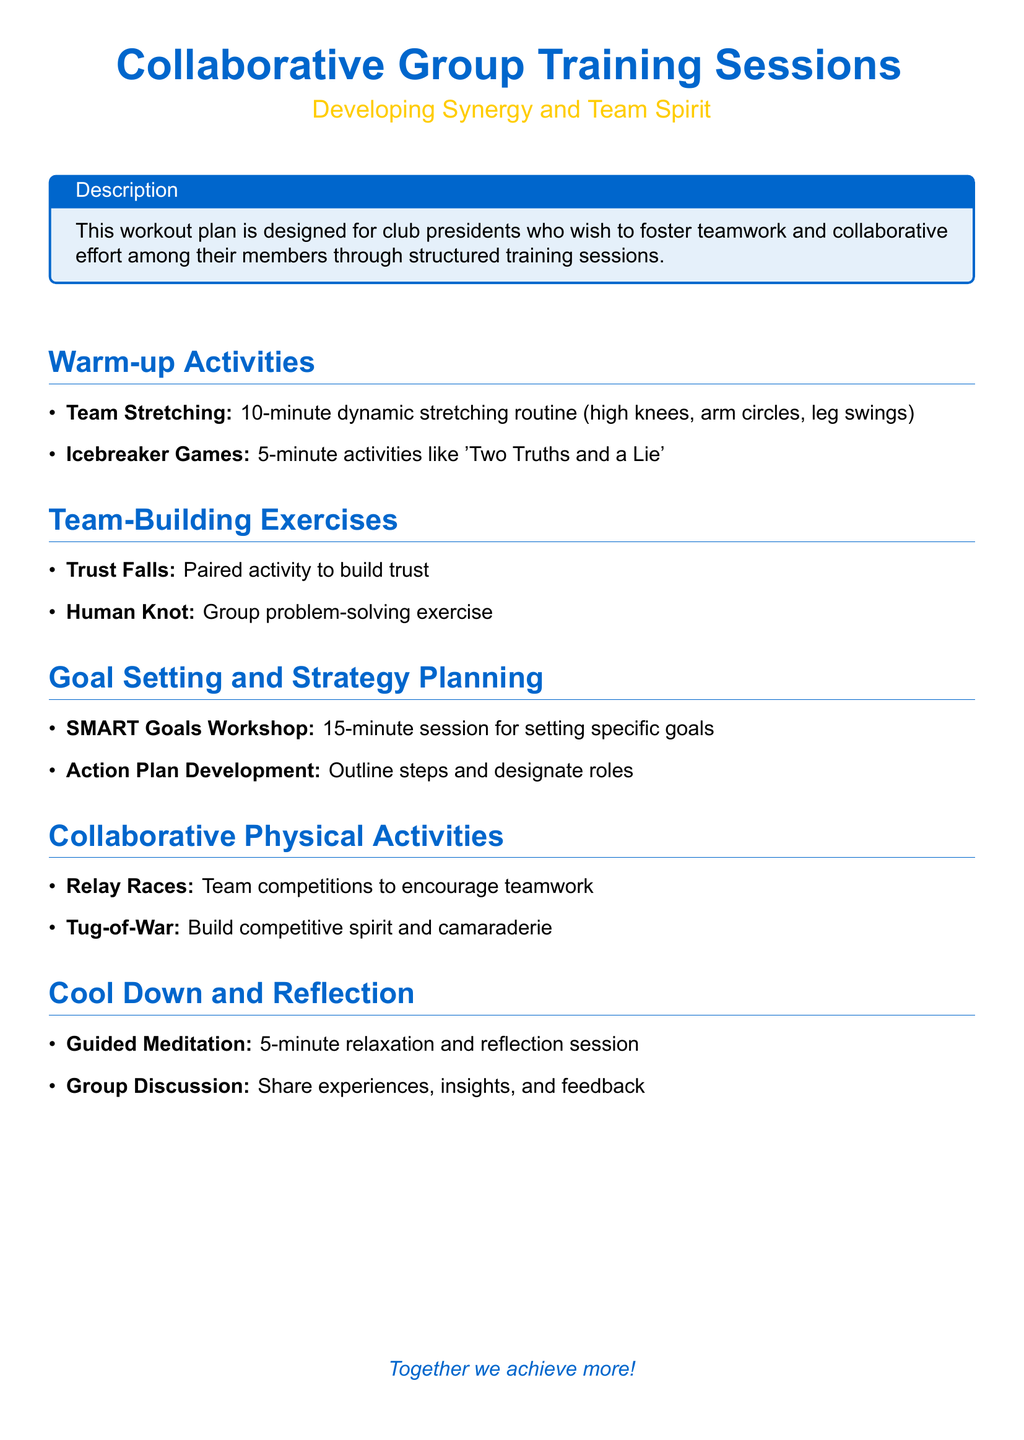What is the title of the document? The title is prominently displayed at the beginning of the document.
Answer: Collaborative Group Training Sessions What color is used for the main title? The main title color is specified in the document format.
Answer: RGB(0,102,204) How long is the dynamic stretching routine? The duration of the team stretching activity is mentioned in the warm-up section.
Answer: 10 minutes What type of exercise is the 'Human Knot'? This exercise is categorized under team-building activities in the document.
Answer: Group problem-solving exercise What workshop is scheduled for goal setting? The workshop focused on goal-setting is listed under the strategy planning section.
Answer: SMART Goals Workshop How many activities are listed under Collaborative Physical Activities? The number of activities in the section is stated.
Answer: Two activities What is the purpose of the Guided Meditation session? The purpose of this session is described within the cool-down section.
Answer: Relaxation and reflection What activity is included to encourage teamwork? This activity is specifically mentioned in the collaborative activities section.
Answer: Relay Races What should participants share during the Group Discussion? The expected outcome of the discussion is outlined in the document.
Answer: Experiences, insights, and feedback 